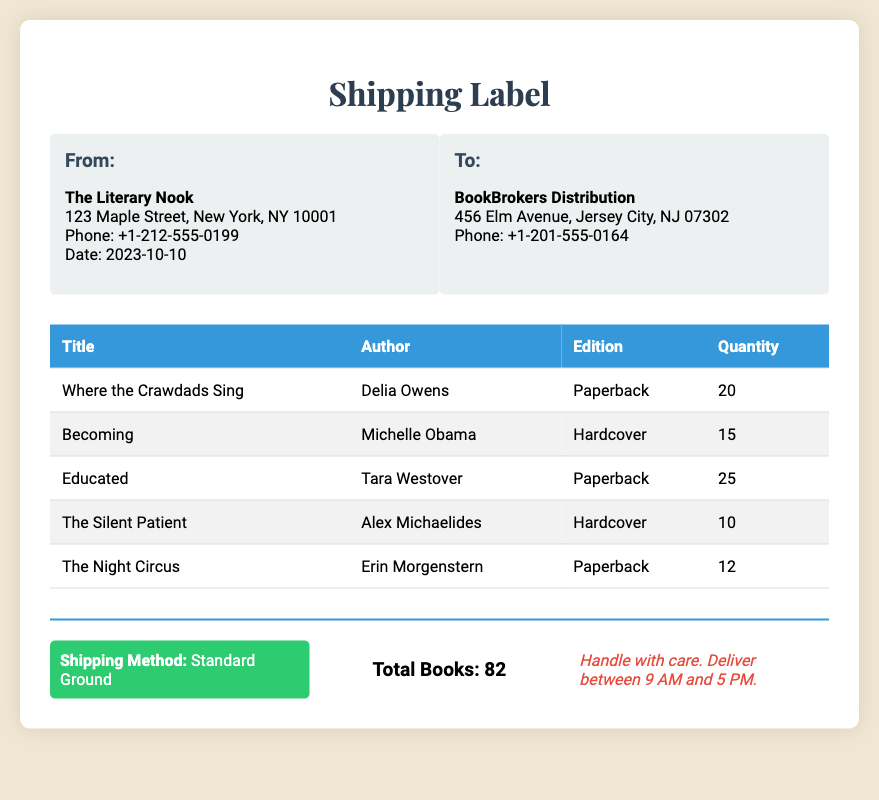What is the sender's name? The sender's name is listed in the "From" section of the document.
Answer: The Literary Nook What is the total quantity of books shipped? The total quantity is stated in the "Total Books" section at the bottom of the document.
Answer: 82 Which shipping method is being used? The shipping method is indicated in the "Shipping Method" section of the footer.
Answer: Standard Ground What is the date on the shipping label? The date is shown in the "From" section of the document.
Answer: 2023-10-10 How many copies of "Becoming" are being shipped? The quantity of "Becoming" can be found in the table under the corresponding title.
Answer: 15 Who is the recipient of the shipment? The recipient's name is provided in the "To" section of the document.
Answer: BookBrokers Distribution What edition of "Educated" is being sent? The edition of "Educated" is detailed in the table alongside the title.
Answer: Paperback What is the total number of hardcover books? The total number of hardcover books can be determined by adding the quantities in the table for hardcover titles.
Answer: 25 What special instructions are given for the delivery? The special instructions are mentioned at the bottom of the document in the footer.
Answer: Handle with care. Deliver between 9 AM and 5 PM 